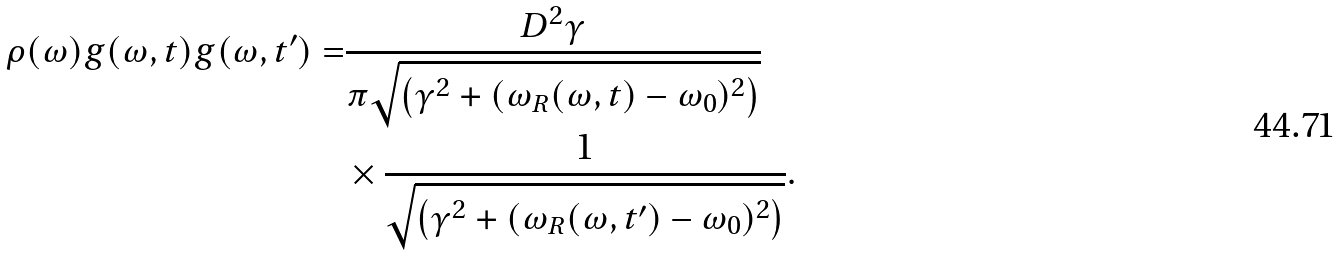Convert formula to latex. <formula><loc_0><loc_0><loc_500><loc_500>\rho ( \omega ) g ( \omega , t ) g ( \omega , t ^ { \prime } ) = & \frac { D ^ { 2 } \gamma } { \pi \sqrt { \left ( \gamma ^ { 2 } + ( \omega _ { R } ( \omega , t ) - \omega _ { 0 } ) ^ { 2 } \right ) } } \\ & \times \frac { 1 } { \sqrt { \left ( \gamma ^ { 2 } + ( \omega _ { R } ( \omega , t ^ { \prime } ) - \omega _ { 0 } ) ^ { 2 } \right ) } } .</formula> 